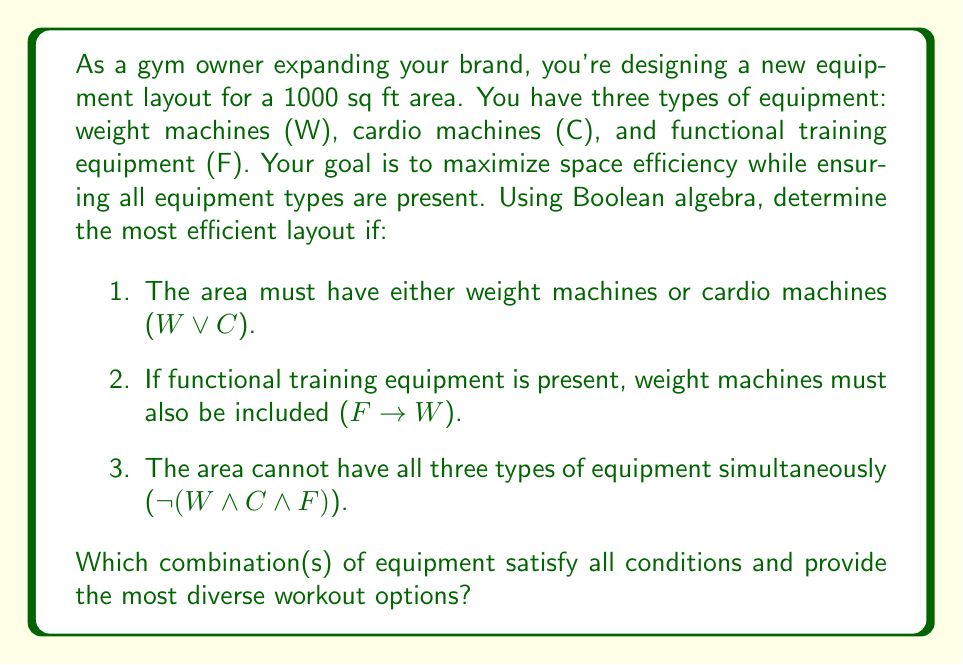Teach me how to tackle this problem. Let's approach this step-by-step using Boolean algebra:

1. First, let's list all possible combinations of equipment:
   $$(W, C, F) = \{(0,0,0), (0,0,1), (0,1,0), (0,1,1), (1,0,0), (1,0,1), (1,1,0), (1,1,1)\}$$

2. Now, let's apply each condition:

   a. $W ∨ C$: This eliminates (0,0,0) and (0,0,1)
   b. $F → W$: This can be rewritten as $¬F ∨ W$. It eliminates (0,1,1)
   c. $¬(W ∧ C ∧ F)$: This eliminates (1,1,1)

3. After applying these conditions, we're left with:
   $$(W, C, F) = \{(0,1,0), (1,0,0), (1,0,1), (1,1,0)\}$$

4. To maximize diversity, we want the combination(s) with the most types of equipment. This leaves us with two options:
   $$(1,1,0)$$ and $$(1,0,1)$$

Both of these combinations include two types of equipment and satisfy all conditions.
Answer: The most efficient layouts that satisfy all conditions and provide the most diverse workout options are:
1. Weight machines and cardio machines $(1,1,0)$
2. Weight machines and functional training equipment $(1,0,1)$ 